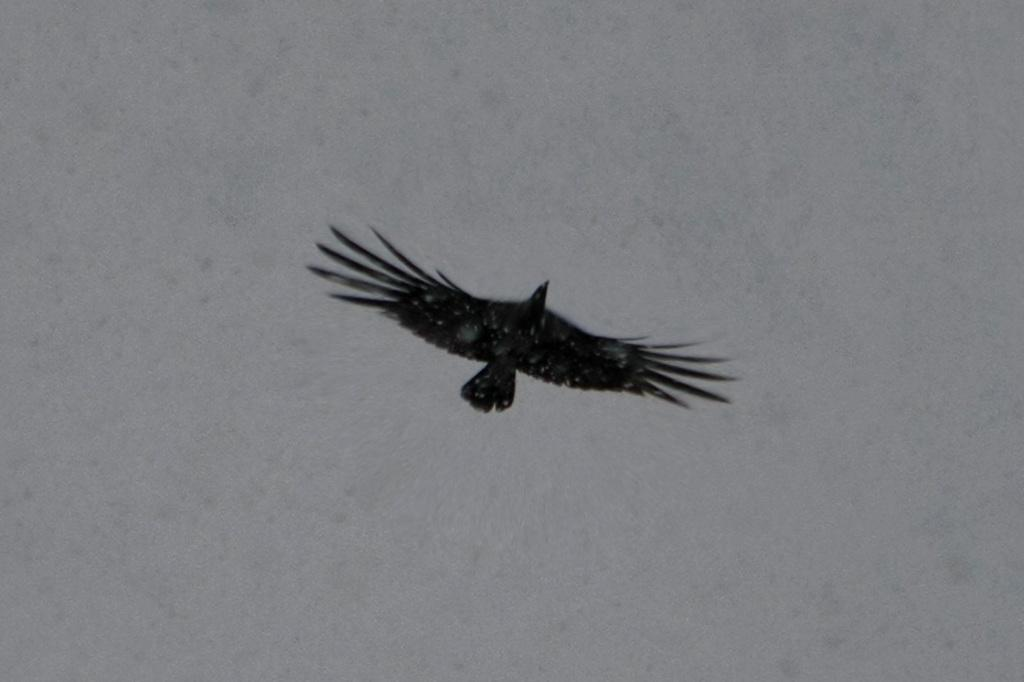What type of animal can be seen in the image? There is a bird in the image. What is the bird doing in the image? The bird is flying in the sky. What type of detail can be seen on the cat's fur in the image? There is no cat present in the image; it features a bird flying in the sky. 